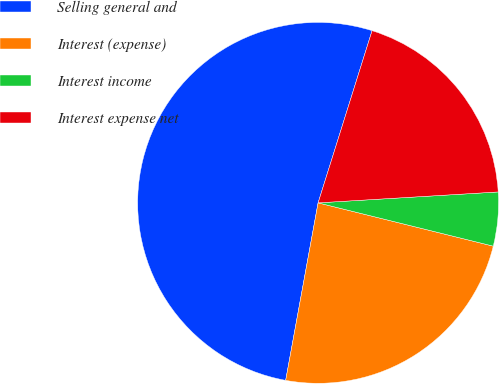Convert chart. <chart><loc_0><loc_0><loc_500><loc_500><pie_chart><fcel>Selling general and<fcel>Interest (expense)<fcel>Interest income<fcel>Interest expense net<nl><fcel>51.96%<fcel>24.02%<fcel>4.82%<fcel>19.2%<nl></chart> 